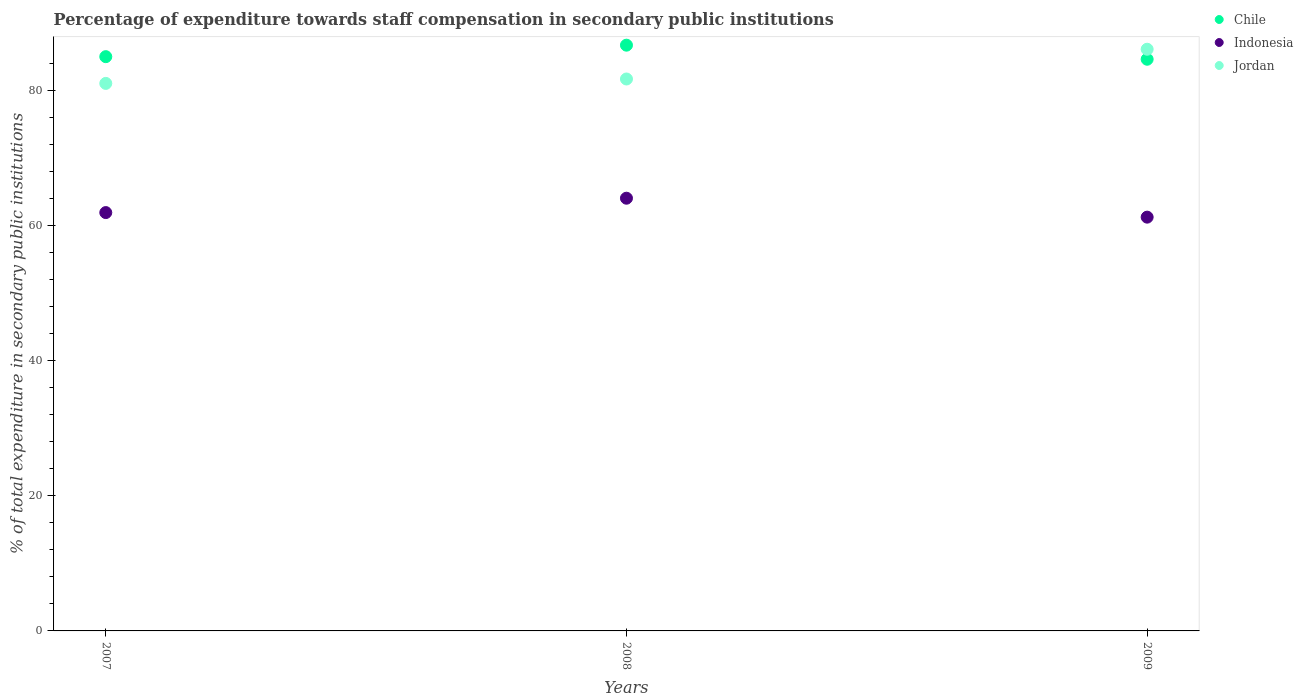What is the percentage of expenditure towards staff compensation in Chile in 2009?
Your answer should be compact. 84.61. Across all years, what is the maximum percentage of expenditure towards staff compensation in Jordan?
Your answer should be very brief. 86.09. Across all years, what is the minimum percentage of expenditure towards staff compensation in Indonesia?
Offer a very short reply. 61.24. In which year was the percentage of expenditure towards staff compensation in Chile minimum?
Provide a short and direct response. 2009. What is the total percentage of expenditure towards staff compensation in Indonesia in the graph?
Give a very brief answer. 187.2. What is the difference between the percentage of expenditure towards staff compensation in Chile in 2007 and that in 2009?
Your answer should be compact. 0.38. What is the difference between the percentage of expenditure towards staff compensation in Chile in 2008 and the percentage of expenditure towards staff compensation in Indonesia in 2009?
Offer a terse response. 25.45. What is the average percentage of expenditure towards staff compensation in Chile per year?
Provide a short and direct response. 85.43. In the year 2007, what is the difference between the percentage of expenditure towards staff compensation in Indonesia and percentage of expenditure towards staff compensation in Chile?
Provide a short and direct response. -23.08. What is the ratio of the percentage of expenditure towards staff compensation in Chile in 2008 to that in 2009?
Your response must be concise. 1.02. Is the percentage of expenditure towards staff compensation in Jordan in 2008 less than that in 2009?
Make the answer very short. Yes. Is the difference between the percentage of expenditure towards staff compensation in Indonesia in 2008 and 2009 greater than the difference between the percentage of expenditure towards staff compensation in Chile in 2008 and 2009?
Offer a very short reply. Yes. What is the difference between the highest and the second highest percentage of expenditure towards staff compensation in Jordan?
Give a very brief answer. 4.4. What is the difference between the highest and the lowest percentage of expenditure towards staff compensation in Jordan?
Your answer should be compact. 5.06. In how many years, is the percentage of expenditure towards staff compensation in Chile greater than the average percentage of expenditure towards staff compensation in Chile taken over all years?
Keep it short and to the point. 1. Is it the case that in every year, the sum of the percentage of expenditure towards staff compensation in Chile and percentage of expenditure towards staff compensation in Jordan  is greater than the percentage of expenditure towards staff compensation in Indonesia?
Provide a succinct answer. Yes. Is the percentage of expenditure towards staff compensation in Jordan strictly less than the percentage of expenditure towards staff compensation in Indonesia over the years?
Provide a short and direct response. No. How many years are there in the graph?
Keep it short and to the point. 3. What is the difference between two consecutive major ticks on the Y-axis?
Ensure brevity in your answer.  20. Are the values on the major ticks of Y-axis written in scientific E-notation?
Provide a short and direct response. No. Does the graph contain grids?
Provide a succinct answer. No. Where does the legend appear in the graph?
Your response must be concise. Top right. What is the title of the graph?
Your response must be concise. Percentage of expenditure towards staff compensation in secondary public institutions. What is the label or title of the X-axis?
Your answer should be very brief. Years. What is the label or title of the Y-axis?
Give a very brief answer. % of total expenditure in secondary public institutions. What is the % of total expenditure in secondary public institutions of Chile in 2007?
Offer a terse response. 84.99. What is the % of total expenditure in secondary public institutions in Indonesia in 2007?
Provide a succinct answer. 61.92. What is the % of total expenditure in secondary public institutions in Jordan in 2007?
Ensure brevity in your answer.  81.03. What is the % of total expenditure in secondary public institutions in Chile in 2008?
Keep it short and to the point. 86.69. What is the % of total expenditure in secondary public institutions of Indonesia in 2008?
Your answer should be compact. 64.04. What is the % of total expenditure in secondary public institutions in Jordan in 2008?
Your answer should be compact. 81.69. What is the % of total expenditure in secondary public institutions of Chile in 2009?
Keep it short and to the point. 84.61. What is the % of total expenditure in secondary public institutions in Indonesia in 2009?
Your answer should be very brief. 61.24. What is the % of total expenditure in secondary public institutions of Jordan in 2009?
Keep it short and to the point. 86.09. Across all years, what is the maximum % of total expenditure in secondary public institutions in Chile?
Offer a very short reply. 86.69. Across all years, what is the maximum % of total expenditure in secondary public institutions in Indonesia?
Keep it short and to the point. 64.04. Across all years, what is the maximum % of total expenditure in secondary public institutions in Jordan?
Give a very brief answer. 86.09. Across all years, what is the minimum % of total expenditure in secondary public institutions of Chile?
Your answer should be compact. 84.61. Across all years, what is the minimum % of total expenditure in secondary public institutions in Indonesia?
Your response must be concise. 61.24. Across all years, what is the minimum % of total expenditure in secondary public institutions of Jordan?
Offer a terse response. 81.03. What is the total % of total expenditure in secondary public institutions in Chile in the graph?
Offer a very short reply. 256.29. What is the total % of total expenditure in secondary public institutions of Indonesia in the graph?
Ensure brevity in your answer.  187.2. What is the total % of total expenditure in secondary public institutions of Jordan in the graph?
Provide a short and direct response. 248.81. What is the difference between the % of total expenditure in secondary public institutions in Chile in 2007 and that in 2008?
Provide a short and direct response. -1.7. What is the difference between the % of total expenditure in secondary public institutions in Indonesia in 2007 and that in 2008?
Your answer should be very brief. -2.13. What is the difference between the % of total expenditure in secondary public institutions in Jordan in 2007 and that in 2008?
Provide a succinct answer. -0.65. What is the difference between the % of total expenditure in secondary public institutions of Chile in 2007 and that in 2009?
Your answer should be very brief. 0.38. What is the difference between the % of total expenditure in secondary public institutions in Indonesia in 2007 and that in 2009?
Your answer should be compact. 0.68. What is the difference between the % of total expenditure in secondary public institutions of Jordan in 2007 and that in 2009?
Ensure brevity in your answer.  -5.06. What is the difference between the % of total expenditure in secondary public institutions in Chile in 2008 and that in 2009?
Your answer should be very brief. 2.08. What is the difference between the % of total expenditure in secondary public institutions of Indonesia in 2008 and that in 2009?
Keep it short and to the point. 2.8. What is the difference between the % of total expenditure in secondary public institutions in Jordan in 2008 and that in 2009?
Your answer should be very brief. -4.4. What is the difference between the % of total expenditure in secondary public institutions of Chile in 2007 and the % of total expenditure in secondary public institutions of Indonesia in 2008?
Provide a short and direct response. 20.95. What is the difference between the % of total expenditure in secondary public institutions in Chile in 2007 and the % of total expenditure in secondary public institutions in Jordan in 2008?
Your answer should be very brief. 3.31. What is the difference between the % of total expenditure in secondary public institutions in Indonesia in 2007 and the % of total expenditure in secondary public institutions in Jordan in 2008?
Your answer should be compact. -19.77. What is the difference between the % of total expenditure in secondary public institutions of Chile in 2007 and the % of total expenditure in secondary public institutions of Indonesia in 2009?
Your answer should be very brief. 23.75. What is the difference between the % of total expenditure in secondary public institutions of Chile in 2007 and the % of total expenditure in secondary public institutions of Jordan in 2009?
Provide a short and direct response. -1.1. What is the difference between the % of total expenditure in secondary public institutions of Indonesia in 2007 and the % of total expenditure in secondary public institutions of Jordan in 2009?
Make the answer very short. -24.18. What is the difference between the % of total expenditure in secondary public institutions of Chile in 2008 and the % of total expenditure in secondary public institutions of Indonesia in 2009?
Keep it short and to the point. 25.45. What is the difference between the % of total expenditure in secondary public institutions of Chile in 2008 and the % of total expenditure in secondary public institutions of Jordan in 2009?
Offer a terse response. 0.6. What is the difference between the % of total expenditure in secondary public institutions in Indonesia in 2008 and the % of total expenditure in secondary public institutions in Jordan in 2009?
Offer a terse response. -22.05. What is the average % of total expenditure in secondary public institutions of Chile per year?
Your response must be concise. 85.43. What is the average % of total expenditure in secondary public institutions in Indonesia per year?
Ensure brevity in your answer.  62.4. What is the average % of total expenditure in secondary public institutions in Jordan per year?
Your answer should be compact. 82.94. In the year 2007, what is the difference between the % of total expenditure in secondary public institutions in Chile and % of total expenditure in secondary public institutions in Indonesia?
Make the answer very short. 23.08. In the year 2007, what is the difference between the % of total expenditure in secondary public institutions of Chile and % of total expenditure in secondary public institutions of Jordan?
Your response must be concise. 3.96. In the year 2007, what is the difference between the % of total expenditure in secondary public institutions in Indonesia and % of total expenditure in secondary public institutions in Jordan?
Your answer should be very brief. -19.12. In the year 2008, what is the difference between the % of total expenditure in secondary public institutions in Chile and % of total expenditure in secondary public institutions in Indonesia?
Provide a short and direct response. 22.65. In the year 2008, what is the difference between the % of total expenditure in secondary public institutions of Chile and % of total expenditure in secondary public institutions of Jordan?
Your answer should be very brief. 5.01. In the year 2008, what is the difference between the % of total expenditure in secondary public institutions in Indonesia and % of total expenditure in secondary public institutions in Jordan?
Offer a terse response. -17.64. In the year 2009, what is the difference between the % of total expenditure in secondary public institutions in Chile and % of total expenditure in secondary public institutions in Indonesia?
Ensure brevity in your answer.  23.37. In the year 2009, what is the difference between the % of total expenditure in secondary public institutions of Chile and % of total expenditure in secondary public institutions of Jordan?
Provide a succinct answer. -1.48. In the year 2009, what is the difference between the % of total expenditure in secondary public institutions of Indonesia and % of total expenditure in secondary public institutions of Jordan?
Offer a very short reply. -24.85. What is the ratio of the % of total expenditure in secondary public institutions in Chile in 2007 to that in 2008?
Your answer should be very brief. 0.98. What is the ratio of the % of total expenditure in secondary public institutions in Indonesia in 2007 to that in 2008?
Your answer should be very brief. 0.97. What is the ratio of the % of total expenditure in secondary public institutions in Chile in 2007 to that in 2009?
Keep it short and to the point. 1. What is the ratio of the % of total expenditure in secondary public institutions in Jordan in 2007 to that in 2009?
Offer a very short reply. 0.94. What is the ratio of the % of total expenditure in secondary public institutions in Chile in 2008 to that in 2009?
Your response must be concise. 1.02. What is the ratio of the % of total expenditure in secondary public institutions in Indonesia in 2008 to that in 2009?
Provide a succinct answer. 1.05. What is the ratio of the % of total expenditure in secondary public institutions of Jordan in 2008 to that in 2009?
Make the answer very short. 0.95. What is the difference between the highest and the second highest % of total expenditure in secondary public institutions of Chile?
Your answer should be compact. 1.7. What is the difference between the highest and the second highest % of total expenditure in secondary public institutions of Indonesia?
Ensure brevity in your answer.  2.13. What is the difference between the highest and the second highest % of total expenditure in secondary public institutions in Jordan?
Offer a very short reply. 4.4. What is the difference between the highest and the lowest % of total expenditure in secondary public institutions in Chile?
Your answer should be compact. 2.08. What is the difference between the highest and the lowest % of total expenditure in secondary public institutions in Indonesia?
Make the answer very short. 2.8. What is the difference between the highest and the lowest % of total expenditure in secondary public institutions in Jordan?
Keep it short and to the point. 5.06. 